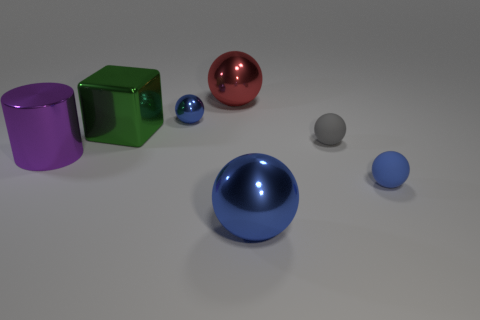What is the material of the cube that is the same size as the purple metal object? The green cube is also made of metal, similar in size to the purple metal object. 